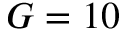Convert formula to latex. <formula><loc_0><loc_0><loc_500><loc_500>G = 1 0</formula> 